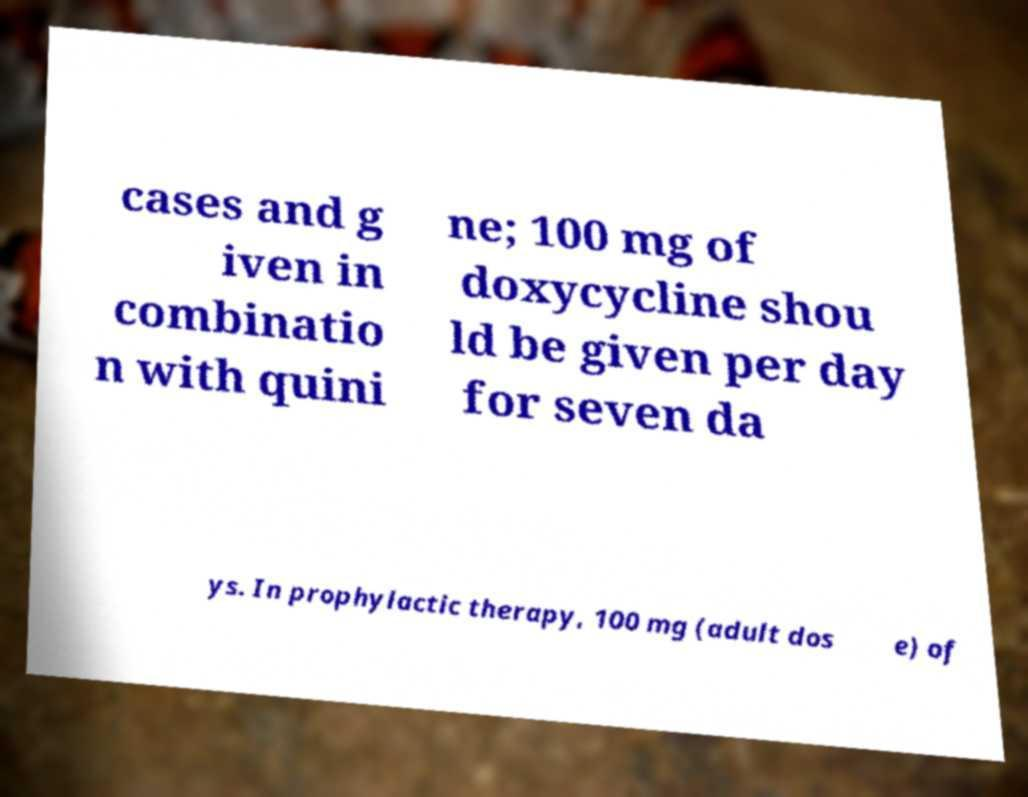Can you read and provide the text displayed in the image?This photo seems to have some interesting text. Can you extract and type it out for me? cases and g iven in combinatio n with quini ne; 100 mg of doxycycline shou ld be given per day for seven da ys. In prophylactic therapy, 100 mg (adult dos e) of 